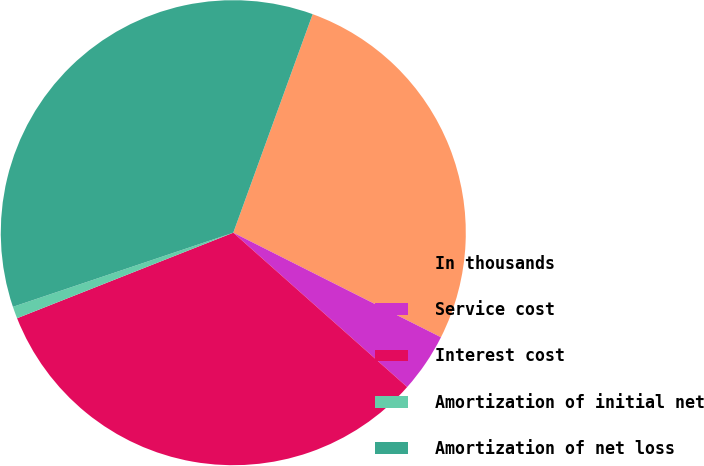Convert chart. <chart><loc_0><loc_0><loc_500><loc_500><pie_chart><fcel>In thousands<fcel>Service cost<fcel>Interest cost<fcel>Amortization of initial net<fcel>Amortization of net loss<nl><fcel>26.88%<fcel>4.13%<fcel>32.45%<fcel>0.83%<fcel>35.71%<nl></chart> 